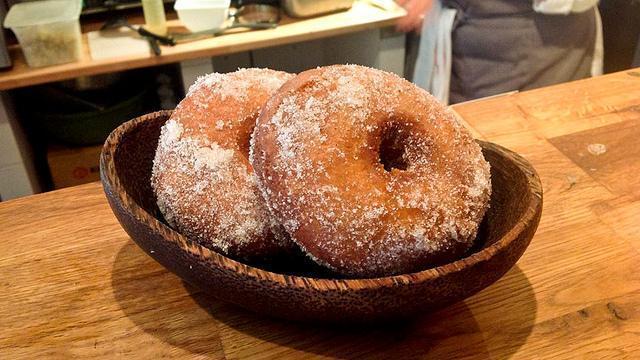Is this affirmation: "The bowl contains the donut." correct?
Answer yes or no. Yes. Verify the accuracy of this image caption: "The donut is inside the bowl.".
Answer yes or no. Yes. 